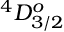<formula> <loc_0><loc_0><loc_500><loc_500>^ { 4 } D _ { 3 / 2 } ^ { o }</formula> 